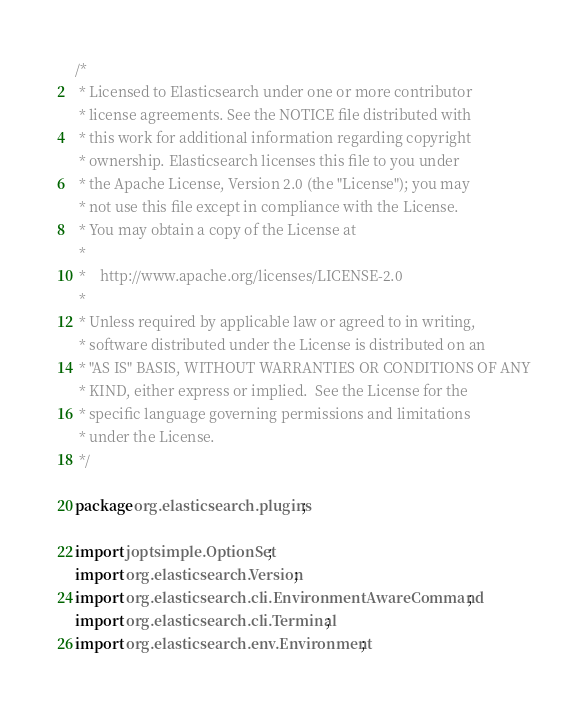<code> <loc_0><loc_0><loc_500><loc_500><_Java_>/*
 * Licensed to Elasticsearch under one or more contributor
 * license agreements. See the NOTICE file distributed with
 * this work for additional information regarding copyright
 * ownership. Elasticsearch licenses this file to you under
 * the Apache License, Version 2.0 (the "License"); you may
 * not use this file except in compliance with the License.
 * You may obtain a copy of the License at
 *
 *    http://www.apache.org/licenses/LICENSE-2.0
 *
 * Unless required by applicable law or agreed to in writing,
 * software distributed under the License is distributed on an
 * "AS IS" BASIS, WITHOUT WARRANTIES OR CONDITIONS OF ANY
 * KIND, either express or implied.  See the License for the
 * specific language governing permissions and limitations
 * under the License.
 */

package org.elasticsearch.plugins;

import joptsimple.OptionSet;
import org.elasticsearch.Version;
import org.elasticsearch.cli.EnvironmentAwareCommand;
import org.elasticsearch.cli.Terminal;
import org.elasticsearch.env.Environment;
</code> 